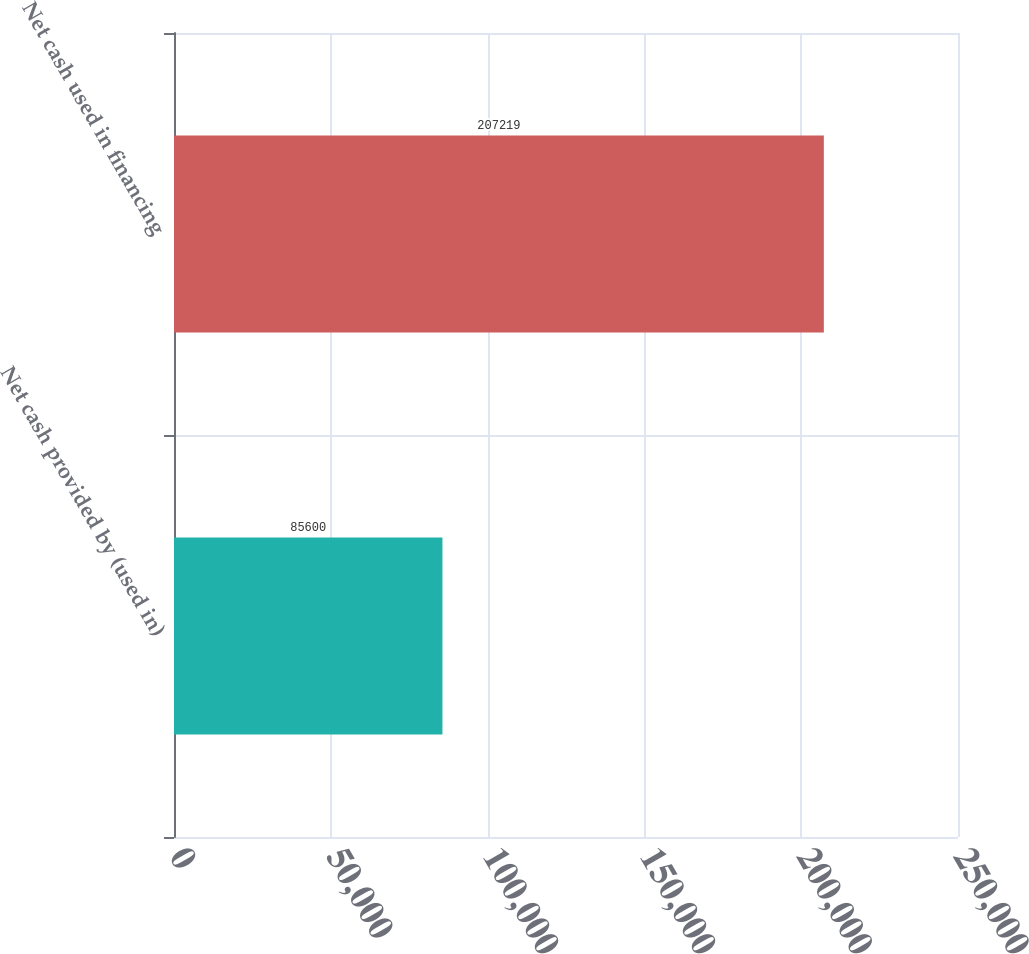<chart> <loc_0><loc_0><loc_500><loc_500><bar_chart><fcel>Net cash provided by (used in)<fcel>Net cash used in financing<nl><fcel>85600<fcel>207219<nl></chart> 